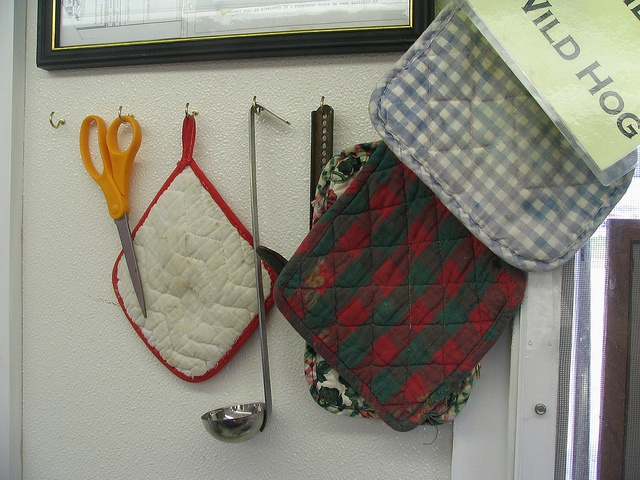Describe the objects in this image and their specific colors. I can see scissors in darkgray, orange, gray, and tan tones and spoon in darkgray, gray, and black tones in this image. 